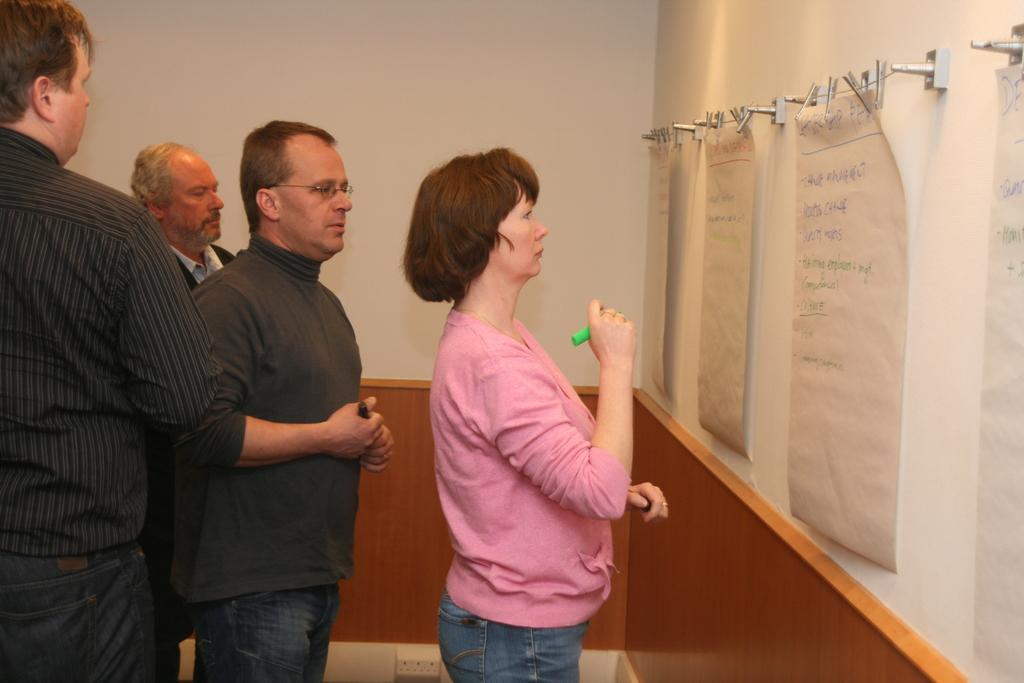What can be seen in the image involving people? There are people standing in the image. What type of decorations are present on the walls? There are wall posters in the image. What is written or depicted on the wall posters? There is text written on the wall posters. What type of fasteners are visible in the image? There are stainless steel clips in the image. What type of surface can be seen in the background? There is a wall visible in the image. What type of shoes are the people wearing in the image? There is no information about the shoes the people are wearing in the image. 